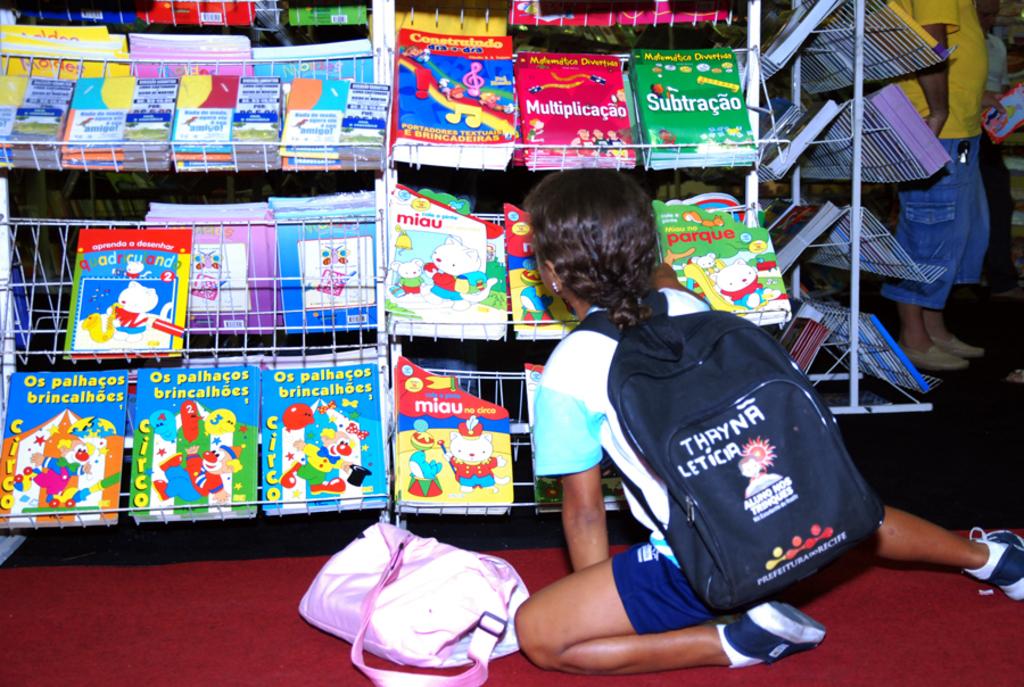What is the title of the book on the bottom left shelf?
Make the answer very short. Os palhacos brincalhoes. 